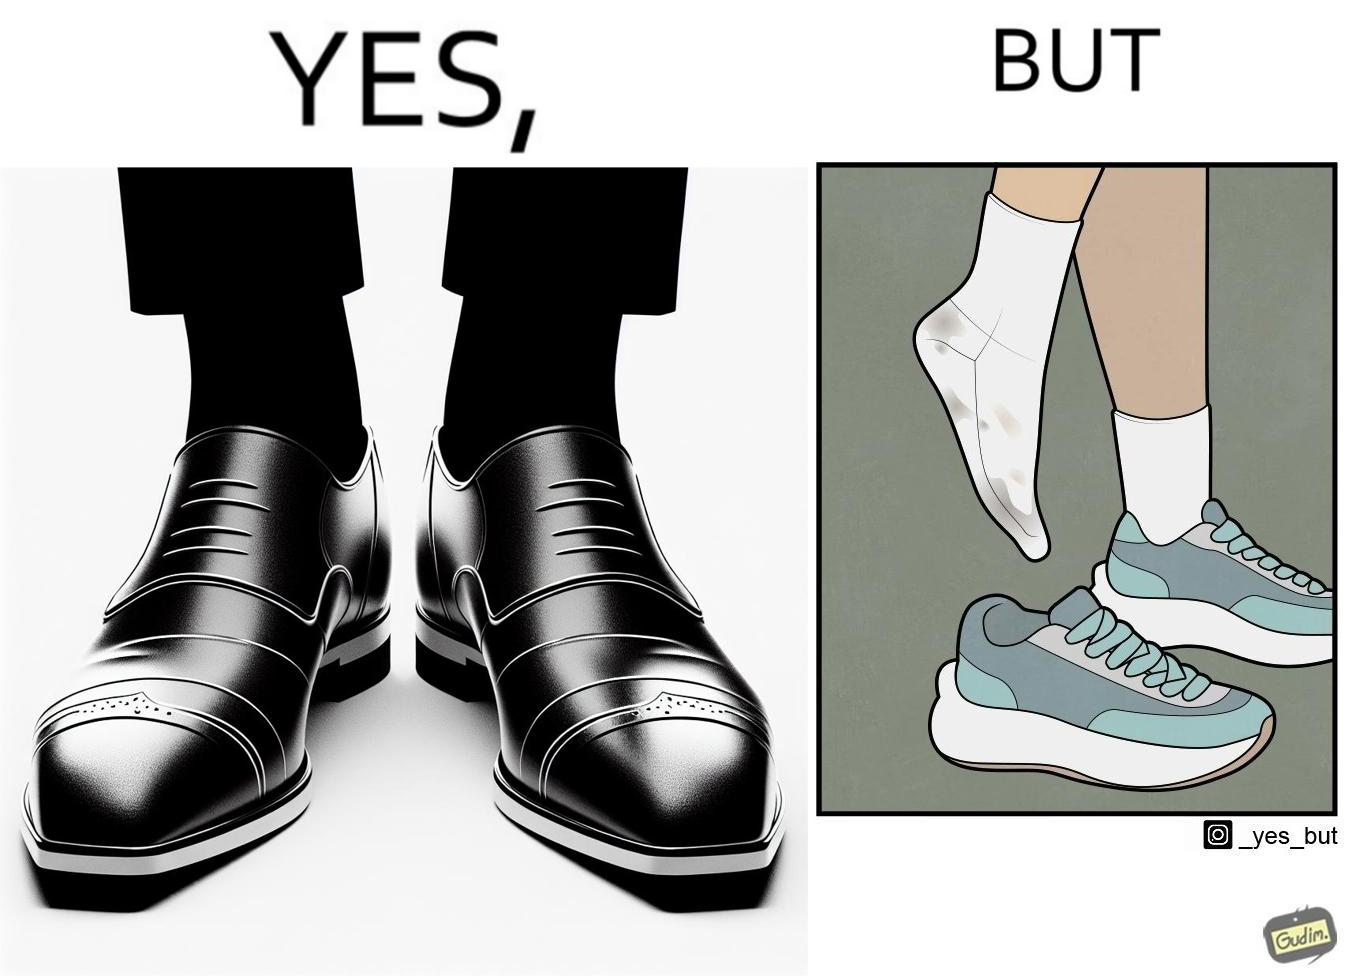Describe the content of this image. The person's shocks is very dirty although the shoes are very clean. Thus there is an irony that not all things are same as they appear. 